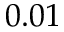<formula> <loc_0><loc_0><loc_500><loc_500>0 . 0 1</formula> 